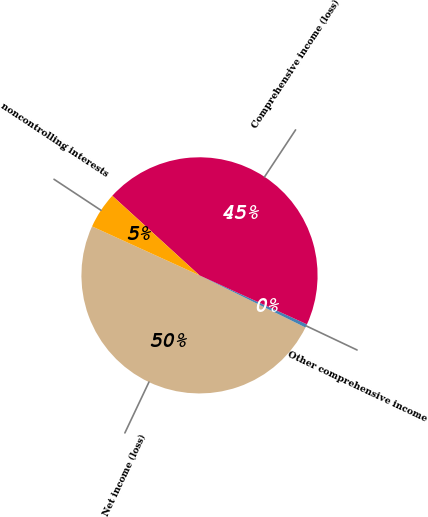Convert chart. <chart><loc_0><loc_0><loc_500><loc_500><pie_chart><fcel>Net income (loss)<fcel>Other comprehensive income<fcel>Comprehensive income (loss)<fcel>noncontrolling interests<nl><fcel>49.53%<fcel>0.47%<fcel>45.03%<fcel>4.97%<nl></chart> 